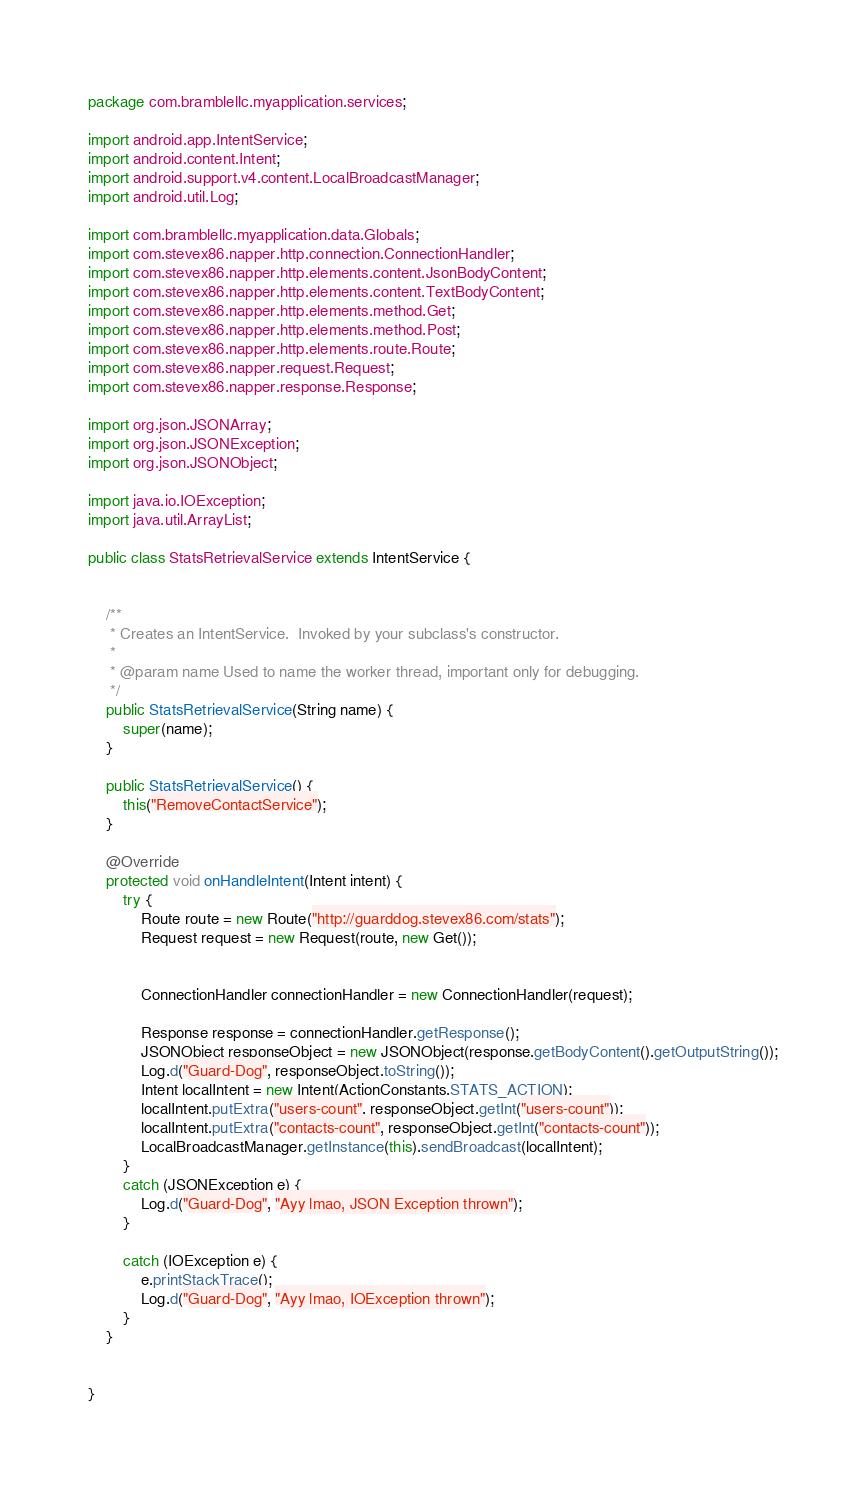Convert code to text. <code><loc_0><loc_0><loc_500><loc_500><_Java_>package com.bramblellc.myapplication.services;

import android.app.IntentService;
import android.content.Intent;
import android.support.v4.content.LocalBroadcastManager;
import android.util.Log;

import com.bramblellc.myapplication.data.Globals;
import com.stevex86.napper.http.connection.ConnectionHandler;
import com.stevex86.napper.http.elements.content.JsonBodyContent;
import com.stevex86.napper.http.elements.content.TextBodyContent;
import com.stevex86.napper.http.elements.method.Get;
import com.stevex86.napper.http.elements.method.Post;
import com.stevex86.napper.http.elements.route.Route;
import com.stevex86.napper.request.Request;
import com.stevex86.napper.response.Response;

import org.json.JSONArray;
import org.json.JSONException;
import org.json.JSONObject;

import java.io.IOException;
import java.util.ArrayList;

public class StatsRetrievalService extends IntentService {


    /**
     * Creates an IntentService.  Invoked by your subclass's constructor.
     *
     * @param name Used to name the worker thread, important only for debugging.
     */
    public StatsRetrievalService(String name) {
        super(name);
    }

    public StatsRetrievalService() {
        this("RemoveContactService");
    }

    @Override
    protected void onHandleIntent(Intent intent) {
        try {
            Route route = new Route("http://guarddog.stevex86.com/stats");
            Request request = new Request(route, new Get());


            ConnectionHandler connectionHandler = new ConnectionHandler(request);

            Response response = connectionHandler.getResponse();
            JSONObject responseObject = new JSONObject(response.getBodyContent().getOutputString());
            Log.d("Guard-Dog", responseObject.toString());
            Intent localIntent = new Intent(ActionConstants.STATS_ACTION);
            localIntent.putExtra("users-count", responseObject.getInt("users-count"));
            localIntent.putExtra("contacts-count", responseObject.getInt("contacts-count"));
            LocalBroadcastManager.getInstance(this).sendBroadcast(localIntent);
        }
        catch (JSONException e) {
            Log.d("Guard-Dog", "Ayy lmao, JSON Exception thrown");
        }

        catch (IOException e) {
            e.printStackTrace();
            Log.d("Guard-Dog", "Ayy lmao, IOException thrown");
        }
    }


}
</code> 